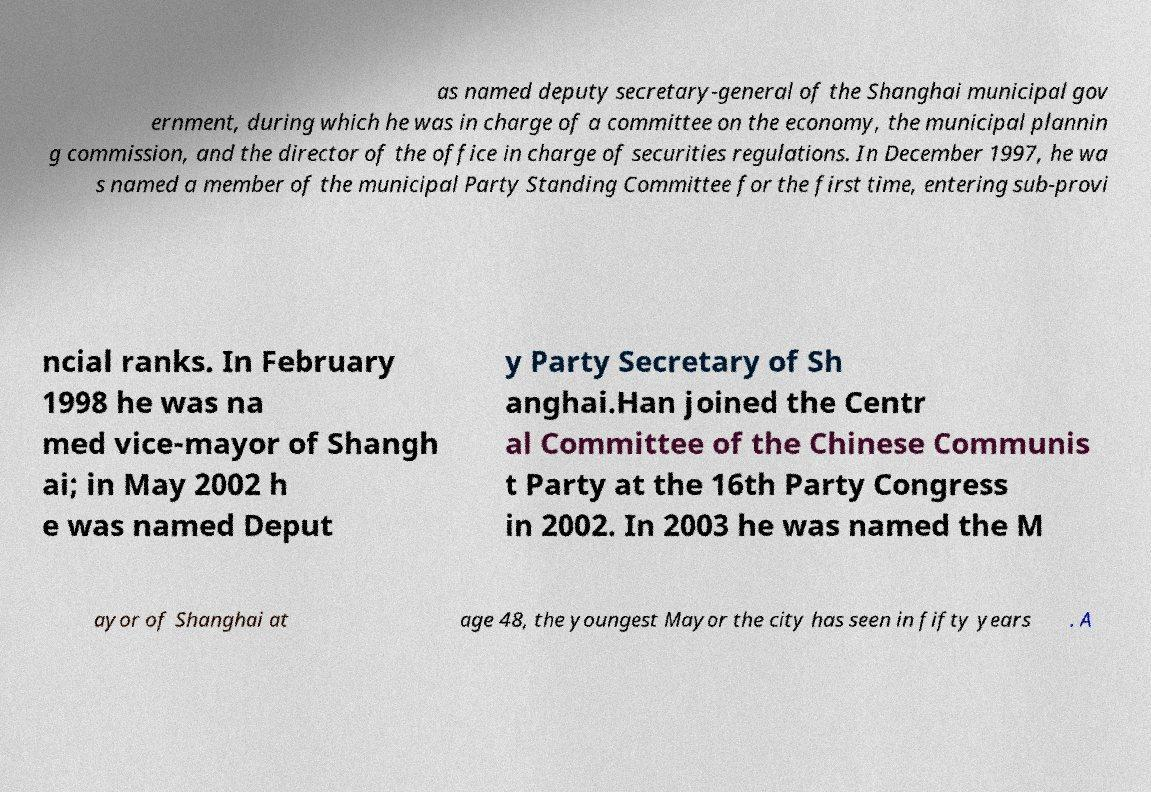I need the written content from this picture converted into text. Can you do that? as named deputy secretary-general of the Shanghai municipal gov ernment, during which he was in charge of a committee on the economy, the municipal plannin g commission, and the director of the office in charge of securities regulations. In December 1997, he wa s named a member of the municipal Party Standing Committee for the first time, entering sub-provi ncial ranks. In February 1998 he was na med vice-mayor of Shangh ai; in May 2002 h e was named Deput y Party Secretary of Sh anghai.Han joined the Centr al Committee of the Chinese Communis t Party at the 16th Party Congress in 2002. In 2003 he was named the M ayor of Shanghai at age 48, the youngest Mayor the city has seen in fifty years . A 